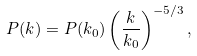Convert formula to latex. <formula><loc_0><loc_0><loc_500><loc_500>P ( k ) = P ( k _ { 0 } ) \left ( \frac { k } { k _ { 0 } } \right ) ^ { - 5 / 3 } ,</formula> 